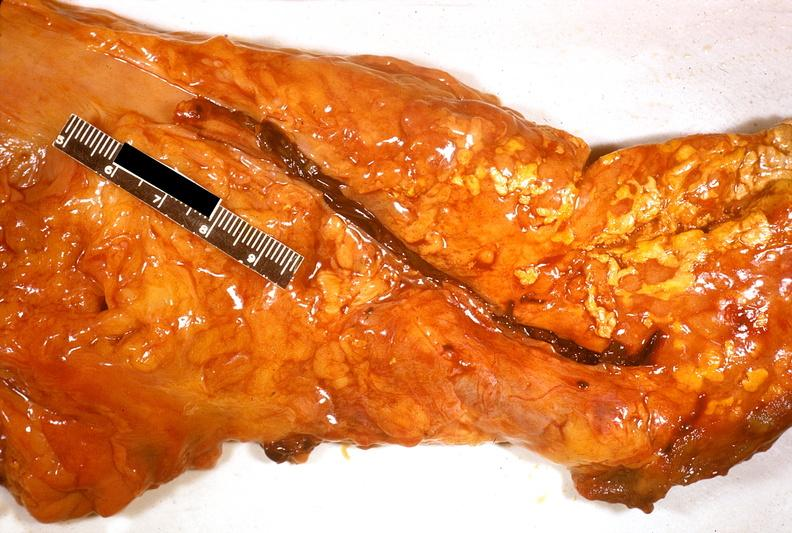does cachexia show acute pancreatitis?
Answer the question using a single word or phrase. No 